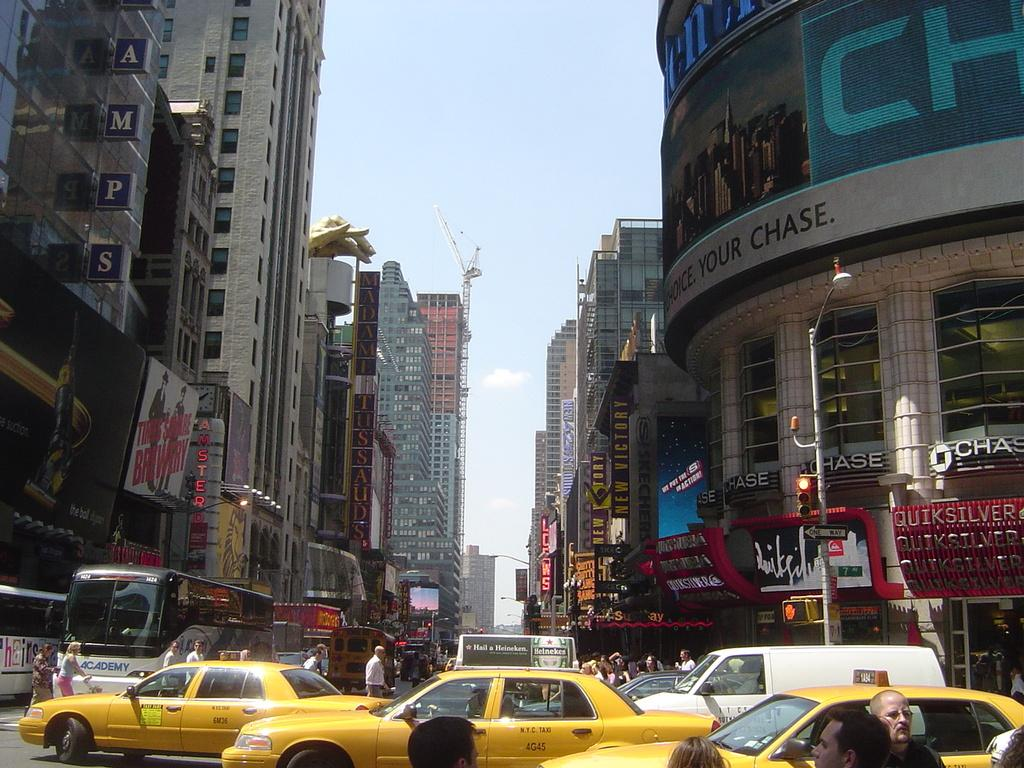<image>
Present a compact description of the photo's key features. A busy downtown street with a Chase bank on the righthand side. 